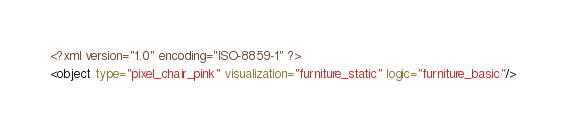Convert code to text. <code><loc_0><loc_0><loc_500><loc_500><_XML_><?xml version="1.0" encoding="ISO-8859-1" ?><object type="pixel_chair_pink" visualization="furniture_static" logic="furniture_basic"/></code> 